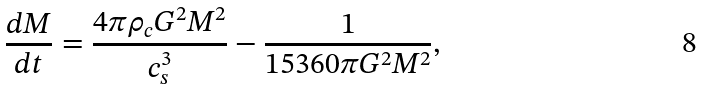<formula> <loc_0><loc_0><loc_500><loc_500>\frac { d M } { d t } = \frac { 4 \pi \rho _ { c } G ^ { 2 } M ^ { 2 } } { c _ { s } ^ { 3 } } - \frac { 1 } { 1 5 3 6 0 \pi G ^ { 2 } M ^ { 2 } } ,</formula> 